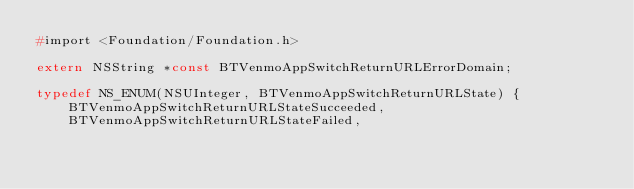<code> <loc_0><loc_0><loc_500><loc_500><_C_>#import <Foundation/Foundation.h>

extern NSString *const BTVenmoAppSwitchReturnURLErrorDomain;

typedef NS_ENUM(NSUInteger, BTVenmoAppSwitchReturnURLState) {
    BTVenmoAppSwitchReturnURLStateSucceeded,
    BTVenmoAppSwitchReturnURLStateFailed,</code> 